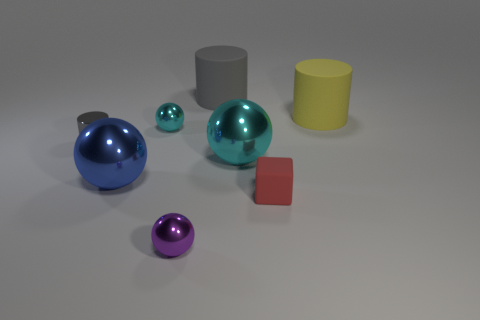Subtract all big gray cylinders. How many cylinders are left? 2 Add 2 big red spheres. How many objects exist? 10 Subtract all blue balls. How many balls are left? 3 Subtract all purple cubes. How many cyan balls are left? 2 Subtract 0 cyan cylinders. How many objects are left? 8 Subtract all cubes. How many objects are left? 7 Subtract 3 cylinders. How many cylinders are left? 0 Subtract all blue cylinders. Subtract all brown spheres. How many cylinders are left? 3 Subtract all large rubber cylinders. Subtract all matte cylinders. How many objects are left? 4 Add 4 small red matte objects. How many small red matte objects are left? 5 